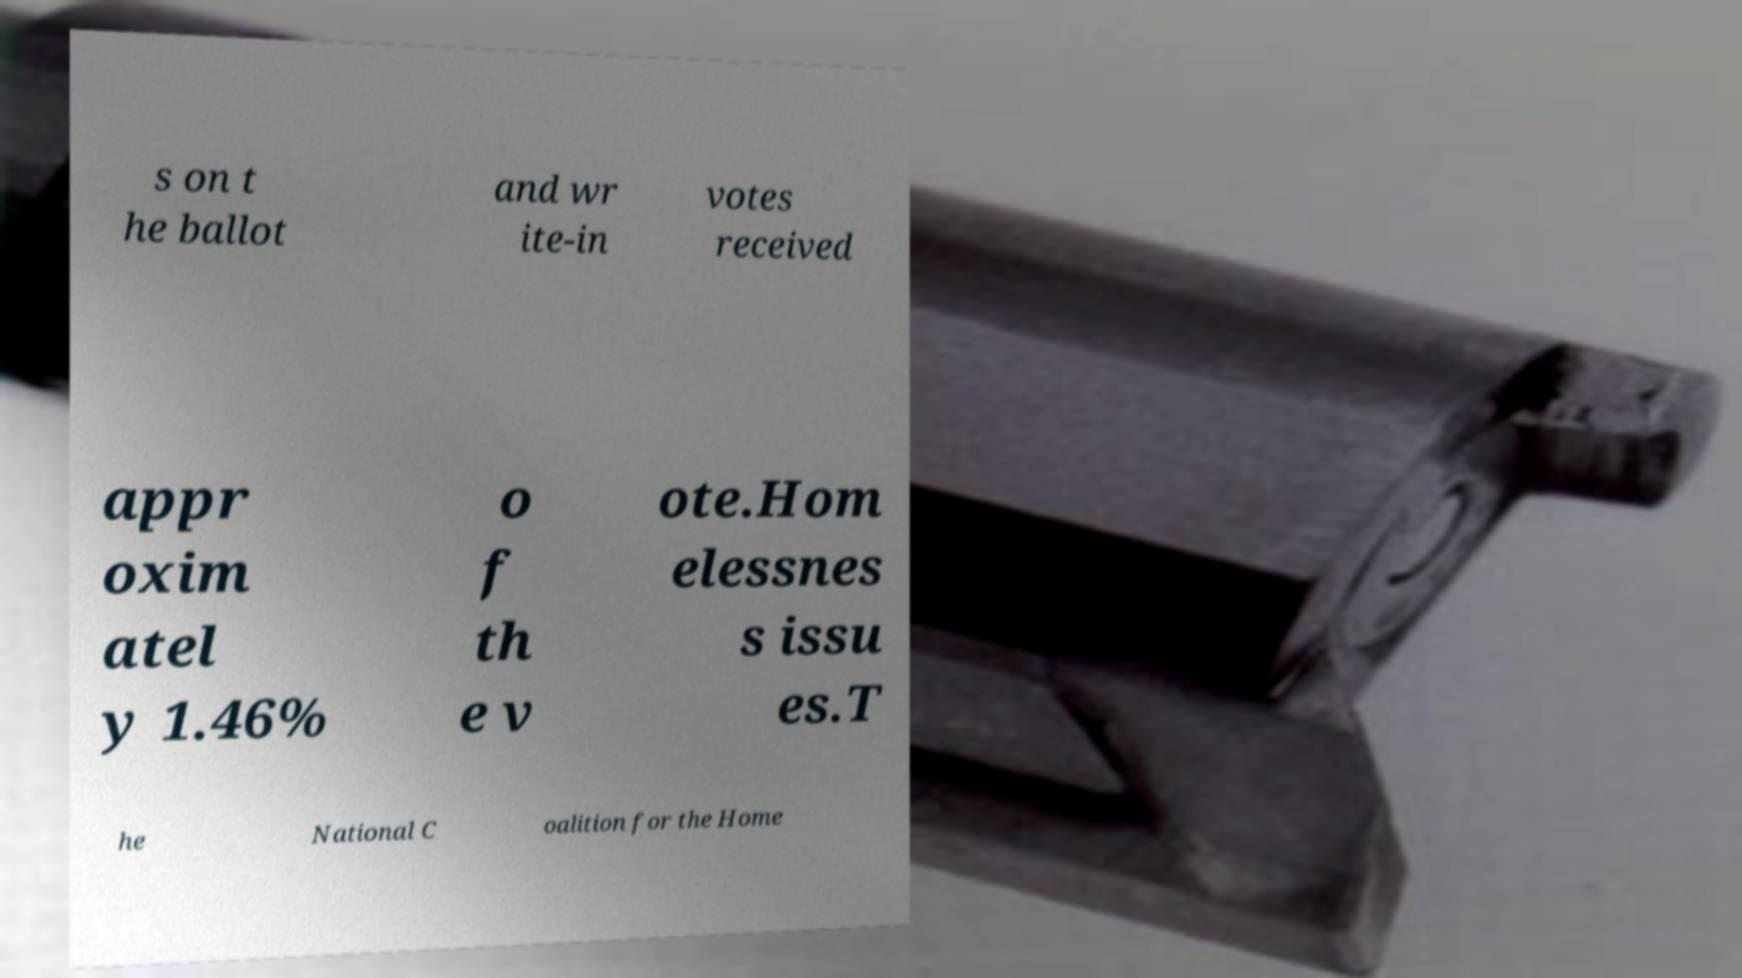I need the written content from this picture converted into text. Can you do that? s on t he ballot and wr ite-in votes received appr oxim atel y 1.46% o f th e v ote.Hom elessnes s issu es.T he National C oalition for the Home 